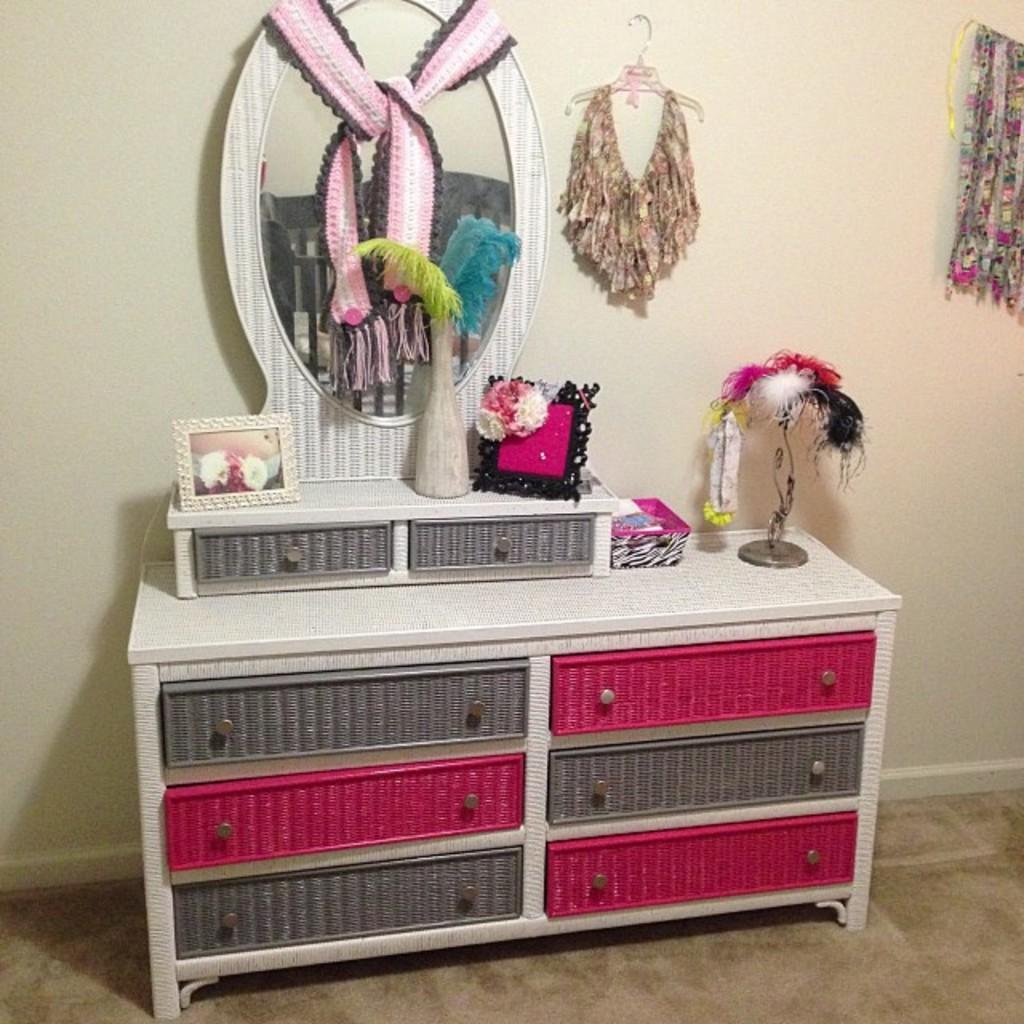Please provide a concise description of this image. Here in this picture we can see a dressing table present on the floor over there and on that we can see different colored drawers present to it and we can see a mirror also present in the middle and we can see some clothes hanging on the hanger over there and we can see some other things placed on the table over there. 